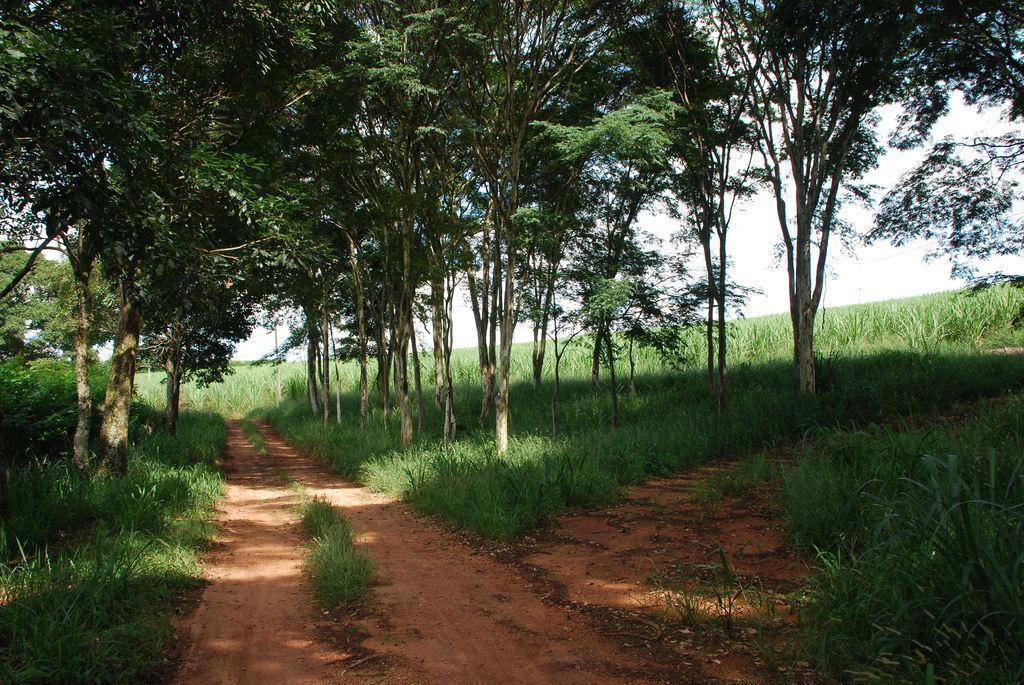How would you summarize this image in a sentence or two? In this image we can see a few trees, plants and grass on the ground, in the background, we can see the sky. 